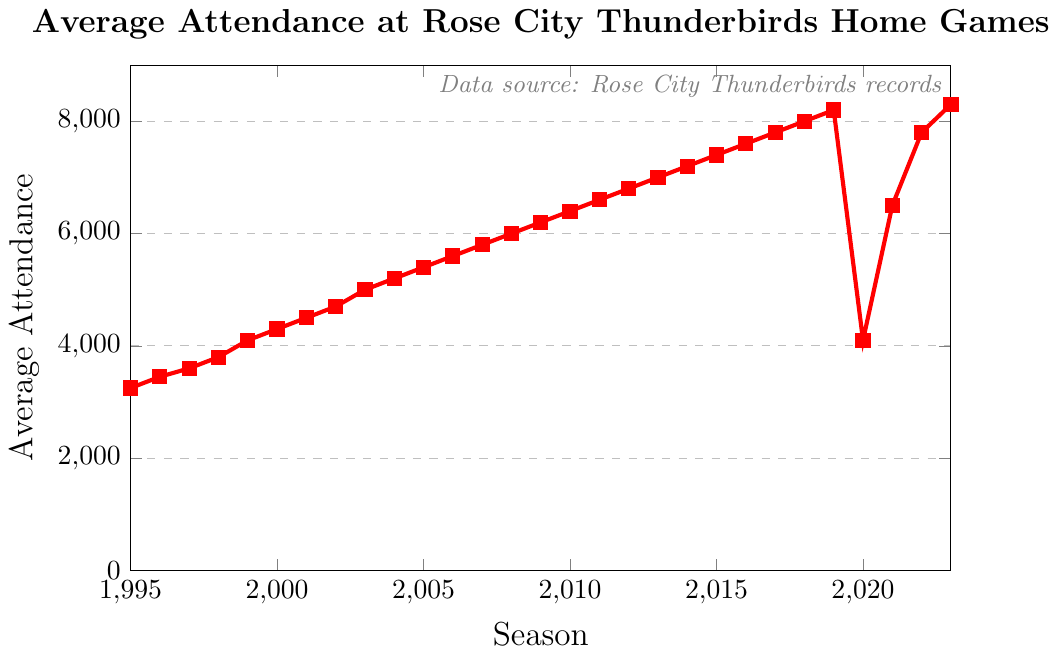What is the average attendance for the first season compared to the last season? The average attendance for the first season (1995) is 3250, and for the last season (2023), it is 8300. Subtracting the initial value from the final gives 8300 - 3250.
Answer: 5050 Which season had the sharpest decrease in average attendance? From the figure, observe the average attendance values. The most noticeable drop occurs between 2019 (8200) and 2020 (4100). By subtracting 4100 from 8200, we get the sharpest decrease.
Answer: 2020 How did the attendance change between 2019 and 2022? In 2019, the attendance was 8200. By 2022, it rose to 7800 after a drop in 2020 to 4100 and subsequent increase in 2021 to 6500. So, 7800 - 8200 gives the overall change.
Answer: -400 What's the average attendance over the entire period from 1995 to 2023? Sum the average attendances for all seasons and then divide by the number of seasons (29). The total sum is \( 3250 + 3450 + 3600 + 3800 + 4100 + 4300 + 4500 + 4700 + 5000 + 5200 + 5400 + 5600 + 5800 + 6000 + 6200 + 6400 + 6600 + 6800 + 7000 + 7200 + 7400 + 7600 + 7800 + 8000 + 8200 + 4100 + 6500 + 7800 + 8300 \). The sum is 172200, divided by 29 gives the average.
Answer: 5938 Which seasons saw growth in attendance for three or more consecutive years? By closely examining the figure, we see growth in average attendance from 1995 to 2003, from 2003 to 2009, and from 2017 to 2019. These are consecutive periods of growth for three or more years. Hence, the seasons are 1995-2003, 2003-2009, and 2017-2019.
Answer: 1995-2003, 2003-2009, 2017-2019 In which season did the average attendance exceed 5,000 for the first time? Trace the average attendance line and identify when it first surpasses the 5,000 mark. It occurs between 2002 (4700) and 2003 (5000). Therefore, 2003 is the season when the attendance first exceeded 5,000.
Answer: 2003 What is the difference in attendance between the seasons 2000 and 2005? Look at the figure for the attendance in both seasons. In 2000, it is 4300, and in 2005, it is 5400. Subtracting the value of 2000 from 2005 attendance: 5400 - 4300.
Answer: 1100 How many seasons had an average attendance above 7000? Count the number of seasons where the average attendance is above 7000. According to the figure, these are from 2013 to 2019, and 2022 to 2023. This totals 9 seasons.
Answer: 9 What is the trend of the average attendance from 2015 to 2019? Observe the graph from 2015 to 2019. The attendance values are 7400, 7600, 7800, 8000, and 8200. The trend is a continuous increase in this period.
Answer: Increasing When did the attendance recover close to pre-2020 values and what was it? The pre-2020 value to compare is 8200 (2019). In 2021, it recovered to 6500 and reached 7800 in 2022, and 8300 in 2023. Hence, by 2023 the attendance recovered close to pre-2020 values.
Answer: 2023 